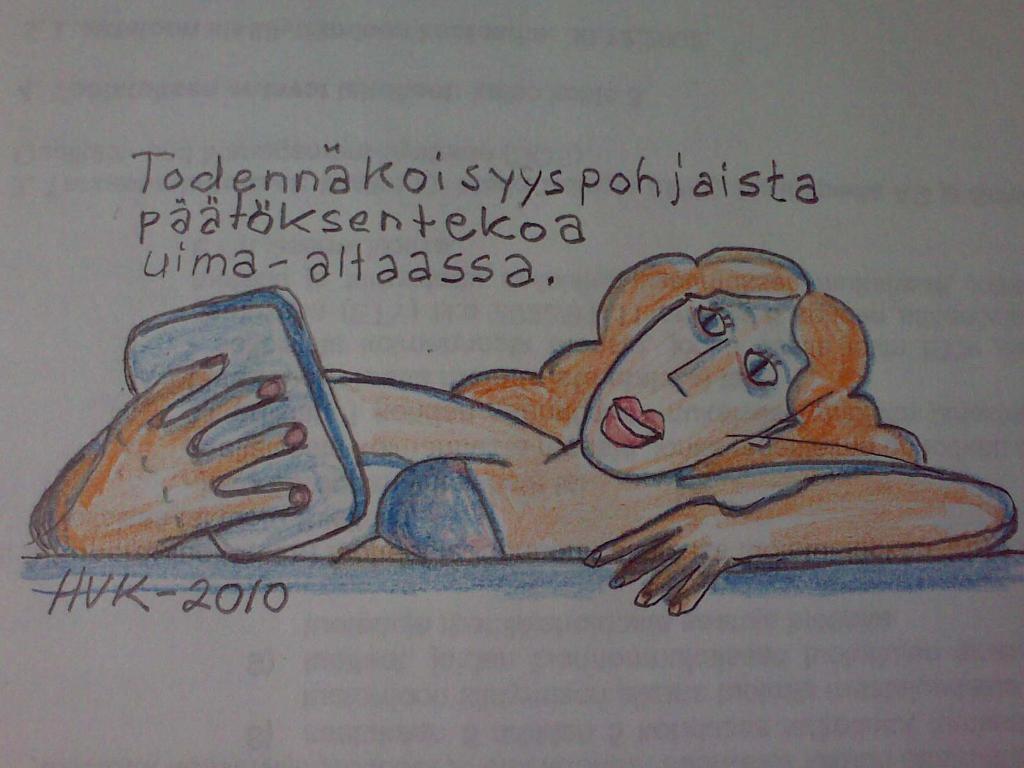Could you give a brief overview of what you see in this image? The picture is a drawing. In the center of the picture there is a woman holding an object, above her there is text. This is a paper. 